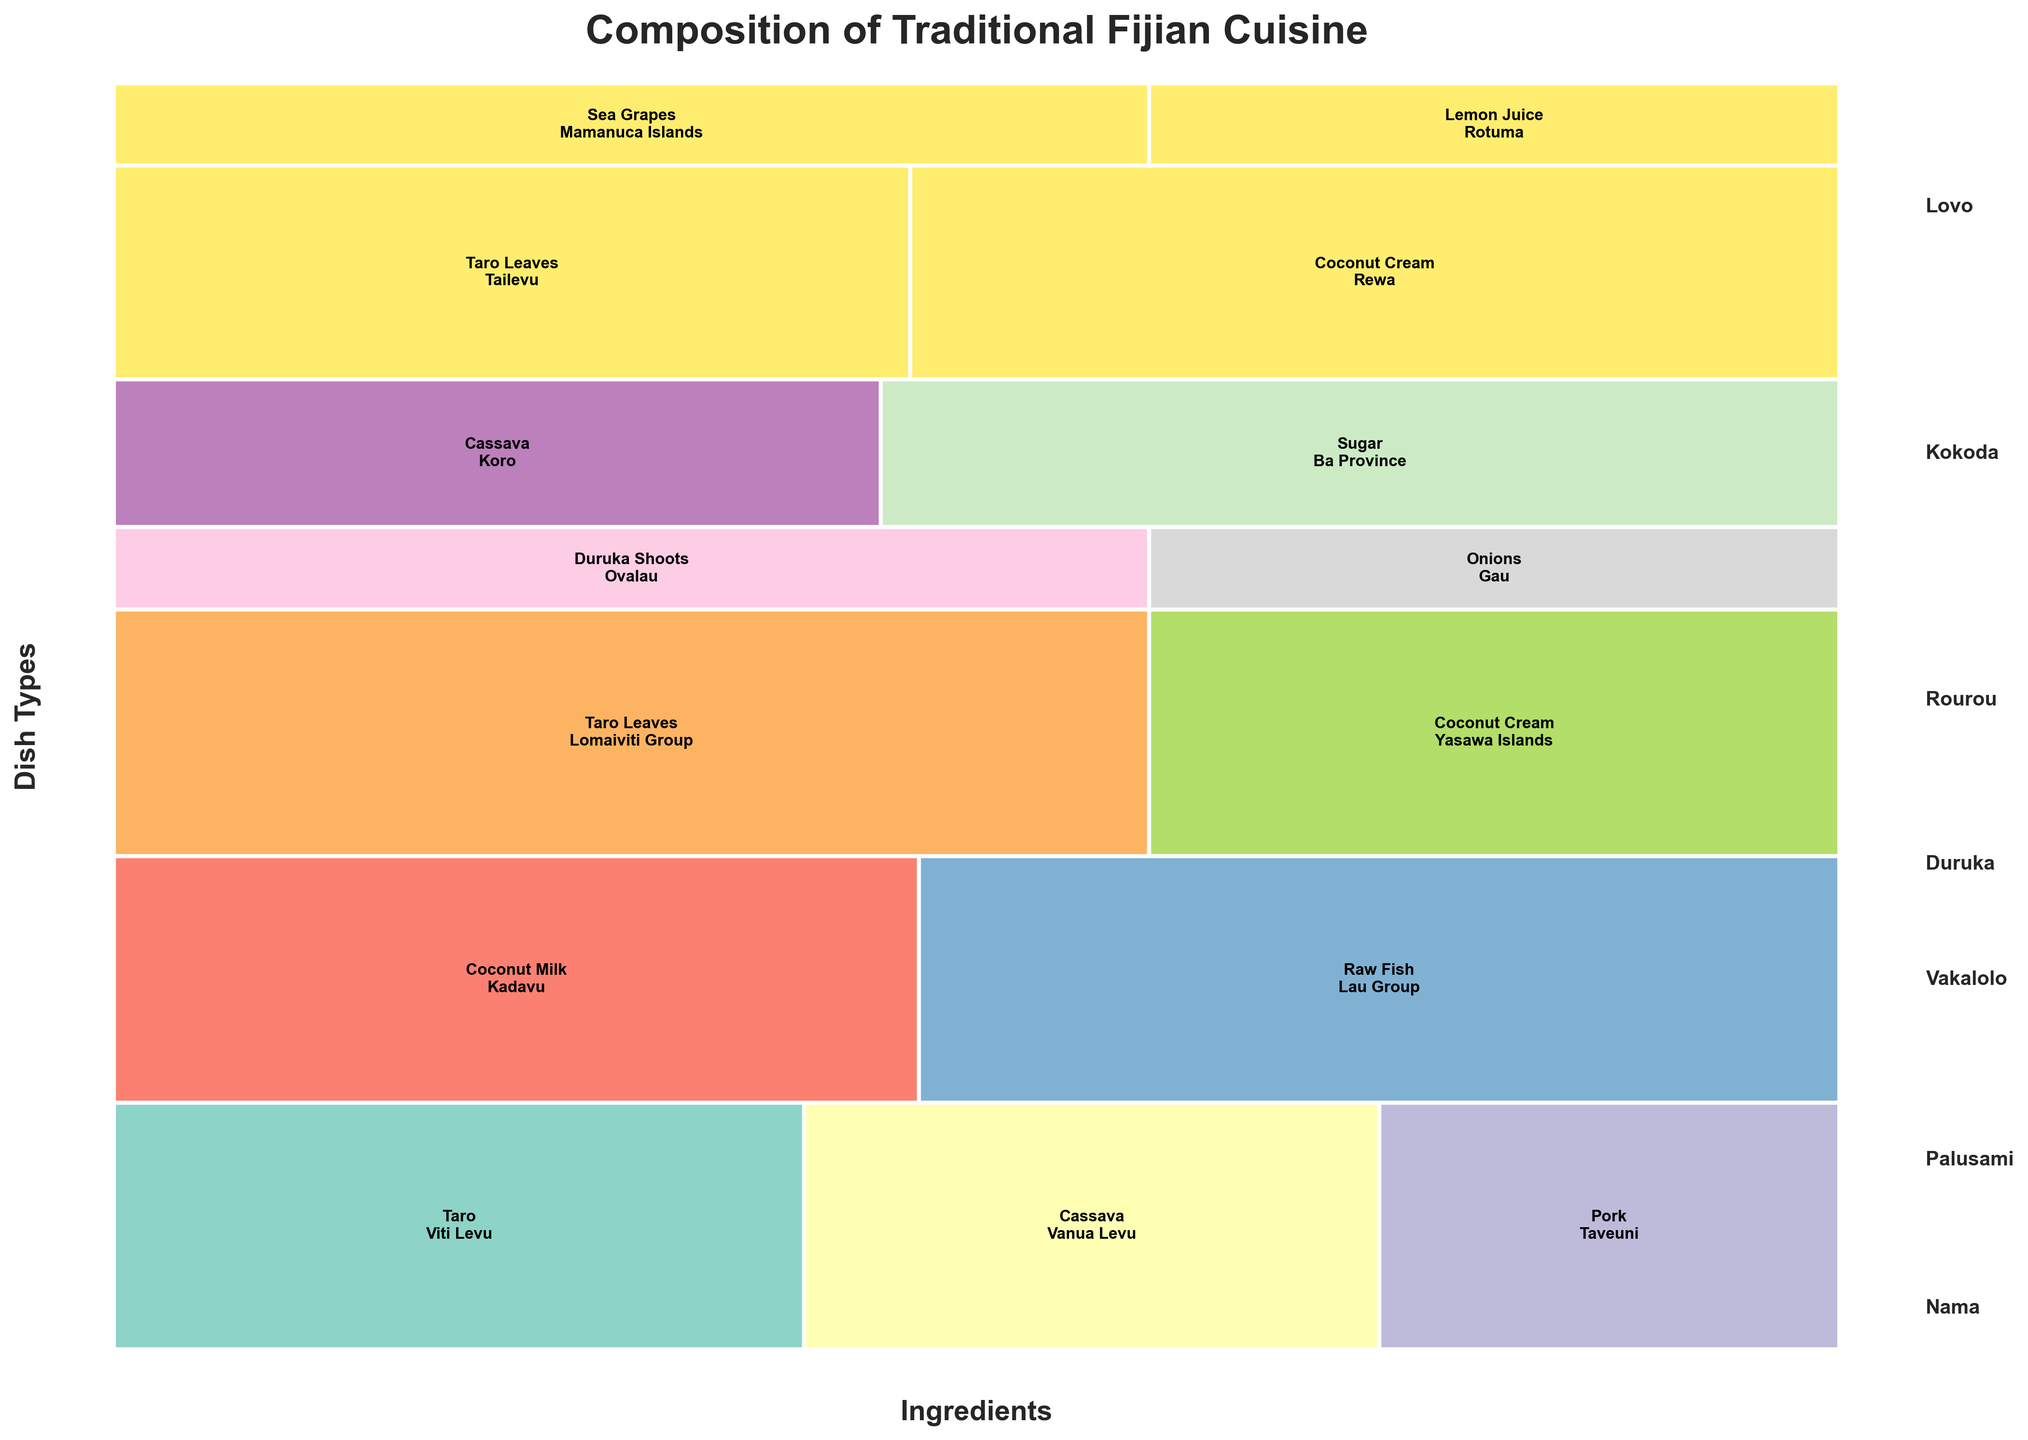What is the title of the plot? The title is typically displayed prominently at the top of the plot.
Answer: Composition of Traditional Fijian Cuisine Which ingredient is most commonly associated with the dish Kokoda? Look for the proportion of ingredients within the Kokoda dish section, the highest is visually identifiable.
Answer: Raw Fish What geographical origin is connected to Duruka Shoots? The geographical origin is labeled within the rectangles representing Duruka Shoots.
Answer: Ovalau What percentage of the Lovo dish is made up of Taro? Calculate the proportion of the area occupied by Taro in the Lovo section. Taro accounts for 30 out of 75 (30+25+20), which is 30/75 = 40%.
Answer: 40% Which two ingredients are used in Vakalolo, and what are their respective origins? Identify the Vakalolo section and observe the ingredients and their associated origins.
Answer: Cassava (Koro) and Sugar (Ba Province) How does the frequency of Taro Leaves in Palusami compare to Rourou? Compare the size of the rectangles representing Taro Leaves in both Palusami and Rourou.
Answer: Same, both are 30 What is the combined frequency of Coconut Cream usage across all dishes? Sum the frequencies of Coconut Cream occurrences in the given data. Coconut Cream appears in Rourou (30) and Palusami (35), thus combined is 30+35.
Answer: 65 Which dish type has the smallest number of ingredients listed? Count the number of unique ingredients for each dish type and identify the least. Duruka has 2 ingredients, which is the least.
Answer: Duruka Are there any ingredients used in more than one geographical region? Check each ingredient to see if it's listed with multiple origins.
Answer: No What ingredient associated with Nama has the lowest frequency, and what is the geographical origin of this ingredient? In the Nama section, compare the frequencies of the ingredients and identify the lowest one.
Answer: Lemon Juice (Rotuma) 